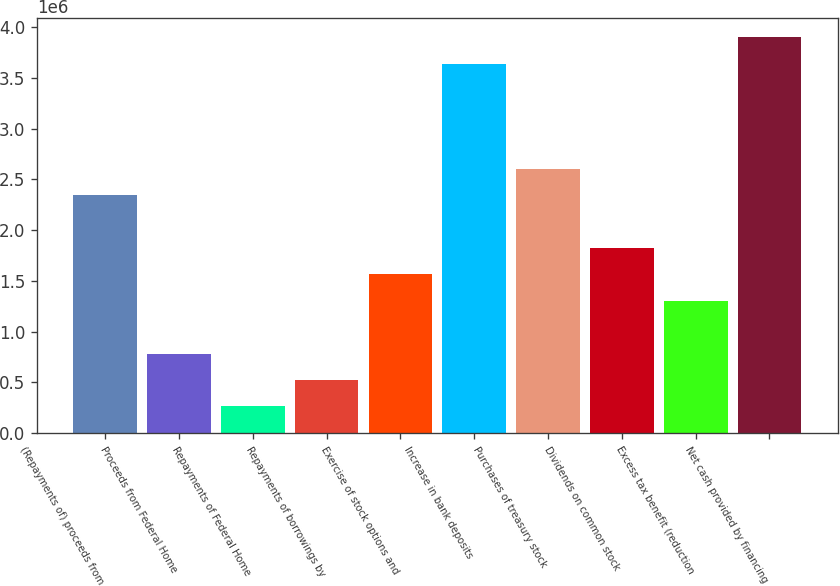Convert chart. <chart><loc_0><loc_0><loc_500><loc_500><bar_chart><fcel>(Repayments of) proceeds from<fcel>Proceeds from Federal Home<fcel>Repayments of Federal Home<fcel>Repayments of borrowings by<fcel>Exercise of stock options and<fcel>Increase in bank deposits<fcel>Purchases of treasury stock<fcel>Dividends on common stock<fcel>Excess tax benefit (reduction<fcel>Net cash provided by financing<nl><fcel>2.34127e+06<fcel>782881<fcel>263417<fcel>523149<fcel>1.56208e+06<fcel>3.63993e+06<fcel>2.60101e+06<fcel>1.82181e+06<fcel>1.30235e+06<fcel>3.89967e+06<nl></chart> 